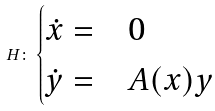<formula> <loc_0><loc_0><loc_500><loc_500>H \colon \begin{cases} \dot { x } = & 0 \\ \dot { y } = & A ( x ) y \end{cases}</formula> 